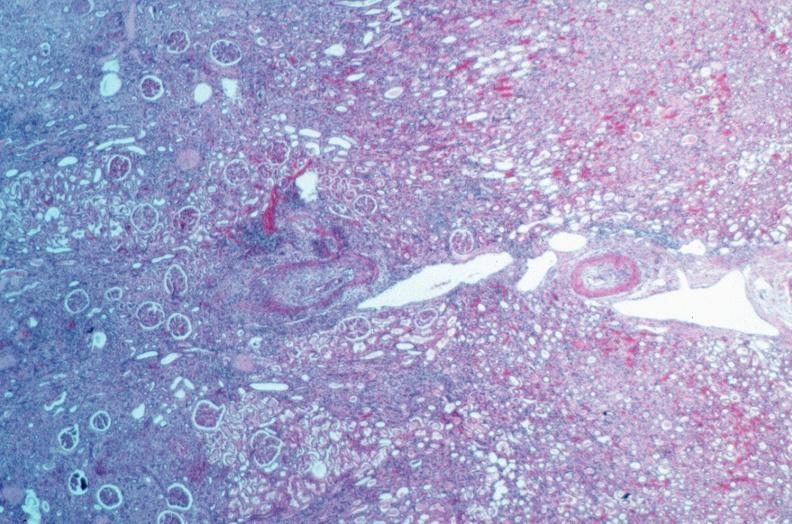does this image show vasculitis, polyarteritis nodosa?
Answer the question using a single word or phrase. Yes 